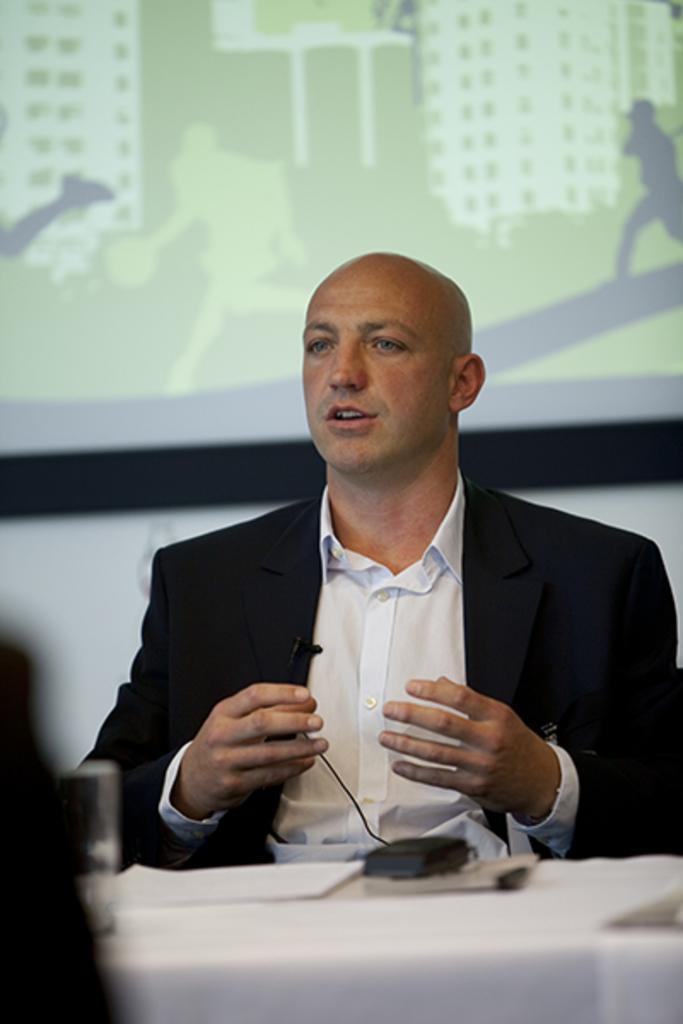Describe this image in one or two sentences. In the center of the image we can see a man sitting. At the bottom there is a table and we can see a glass, paper, mic and some objects placed on the table. In the background there is a screen and a wall. 